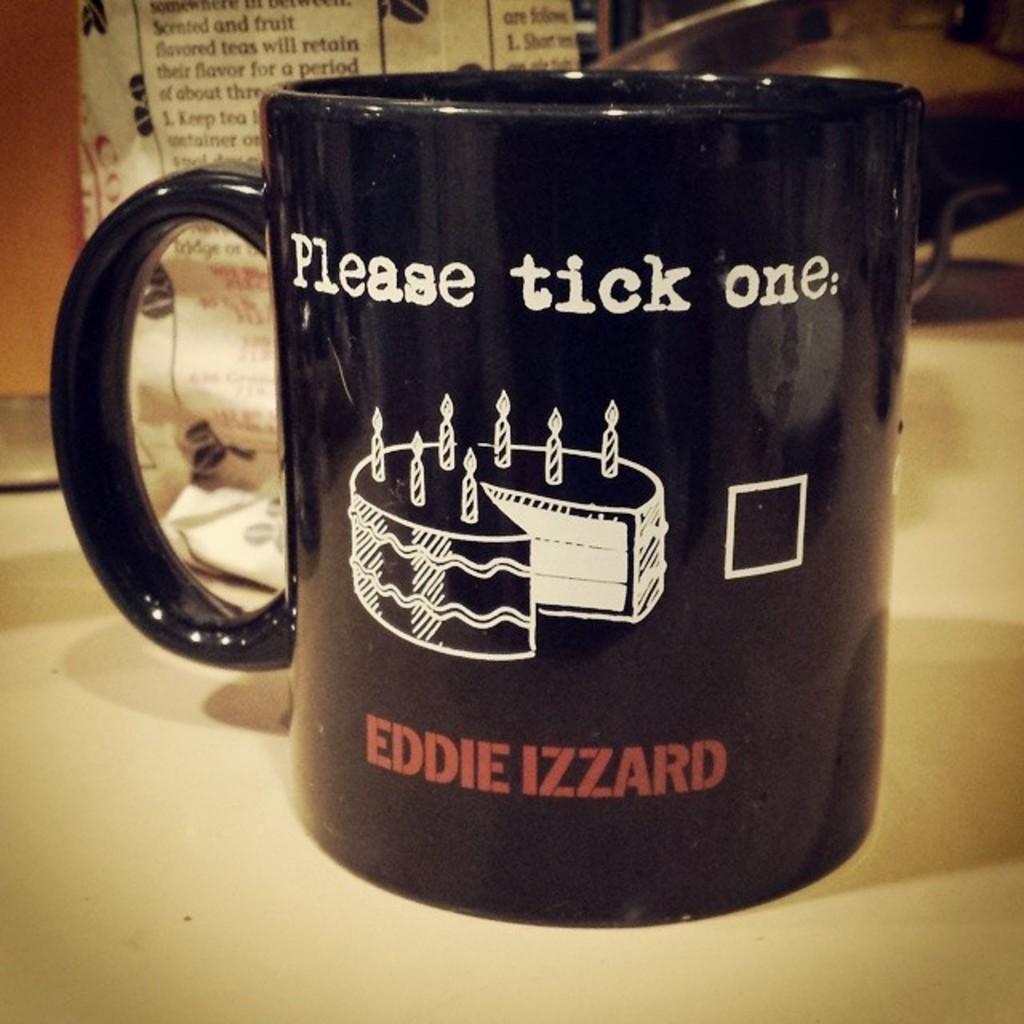Please tick how many?
Keep it short and to the point. One. Who's mug is this?
Make the answer very short. Eddie izzard. 